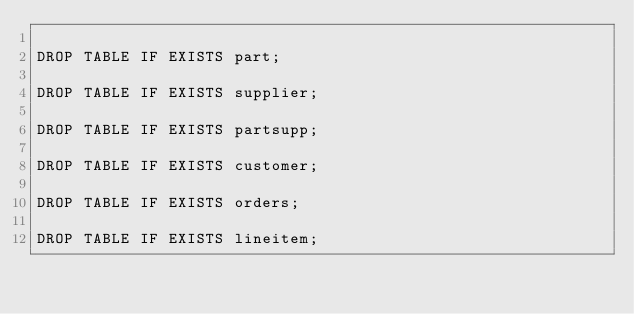<code> <loc_0><loc_0><loc_500><loc_500><_SQL_>
DROP TABLE IF EXISTS part;

DROP TABLE IF EXISTS supplier;

DROP TABLE IF EXISTS partsupp;

DROP TABLE IF EXISTS customer;

DROP TABLE IF EXISTS orders;

DROP TABLE IF EXISTS lineitem;</code> 